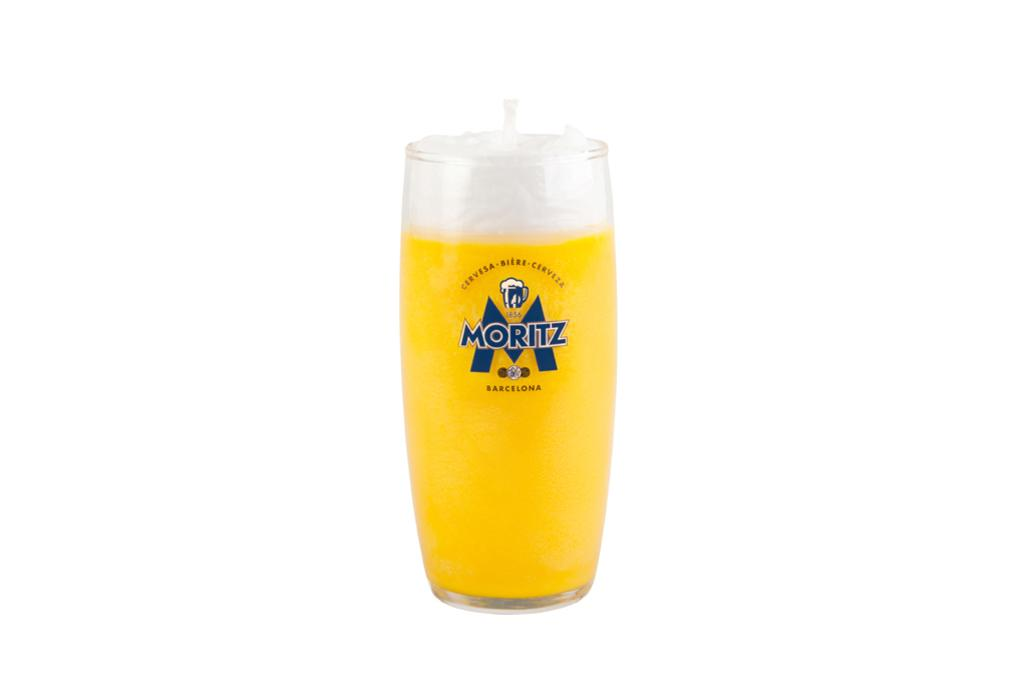Provide a one-sentence caption for the provided image. A large glass completely full of Moritz beer. 